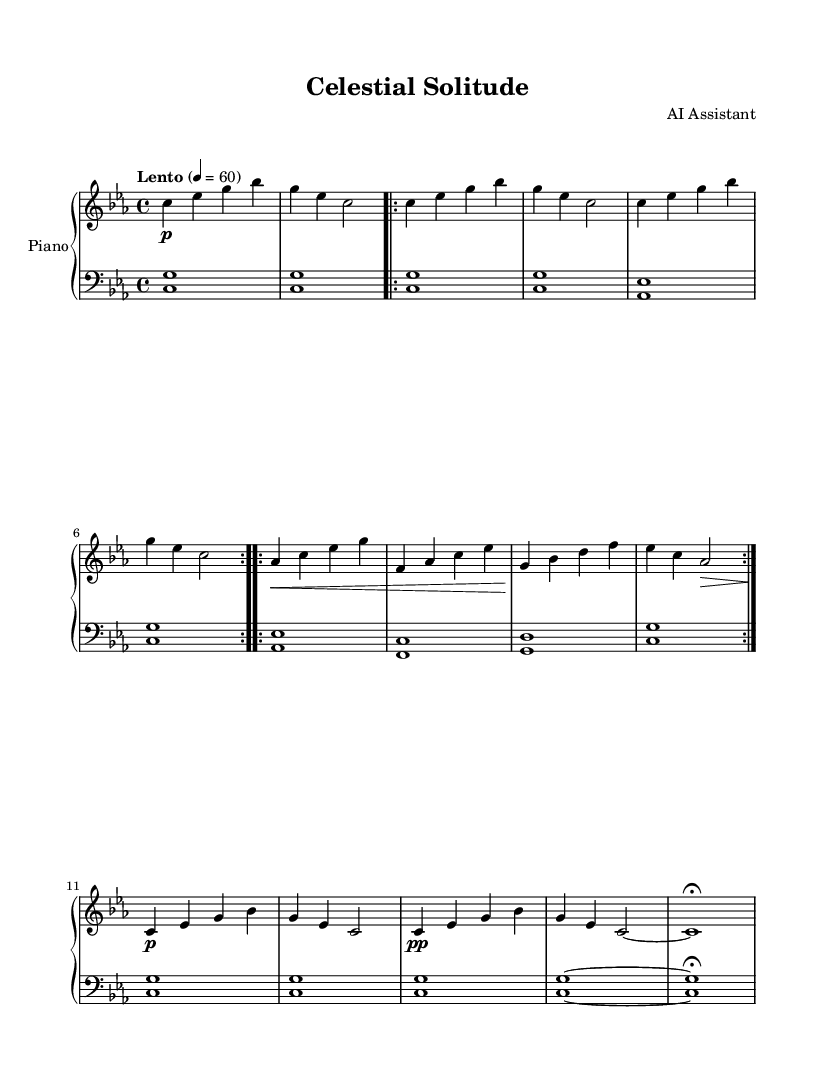What is the key signature of this music? The key signature is C minor, which includes three flats: B flat, E flat, and A flat. This information is shown at the beginning of the music notation.
Answer: C minor What is the time signature of this piece? The time signature is 4/4, which is indicated right after the key signature at the beginning of the sheet. This means there are four beats in each measure.
Answer: 4/4 What is the indicated tempo marking? The tempo marking is "Lento," which directs the performer to play slowly. The metronome marking of 60 beats per minute follows this term, giving a precise pace.
Answer: Lento How many times is the A section repeated? The A section is marked with "repeat volta 2," indicating that it should be played two times in total. This is clearly labeled within the sheet music.
Answer: 2 In the B section, which two notes are played at the beginning of the first measure? The first measure of the B section starts with the notes A flat and C in the upper staff, indicated as "aes" and "c" in the notation.
Answer: A flat, C What dynamic marking occurs in the outro? The outro features a dynamic marking of "pp," which indicates to play very softly. This can be seen in the last measures of the music.
Answer: pp What is the final note in the piece? The final note in the piece is C, which is held out with a fermata, indicating that it is to be sustained longer than usual. This is reflected in the last measure.
Answer: C 